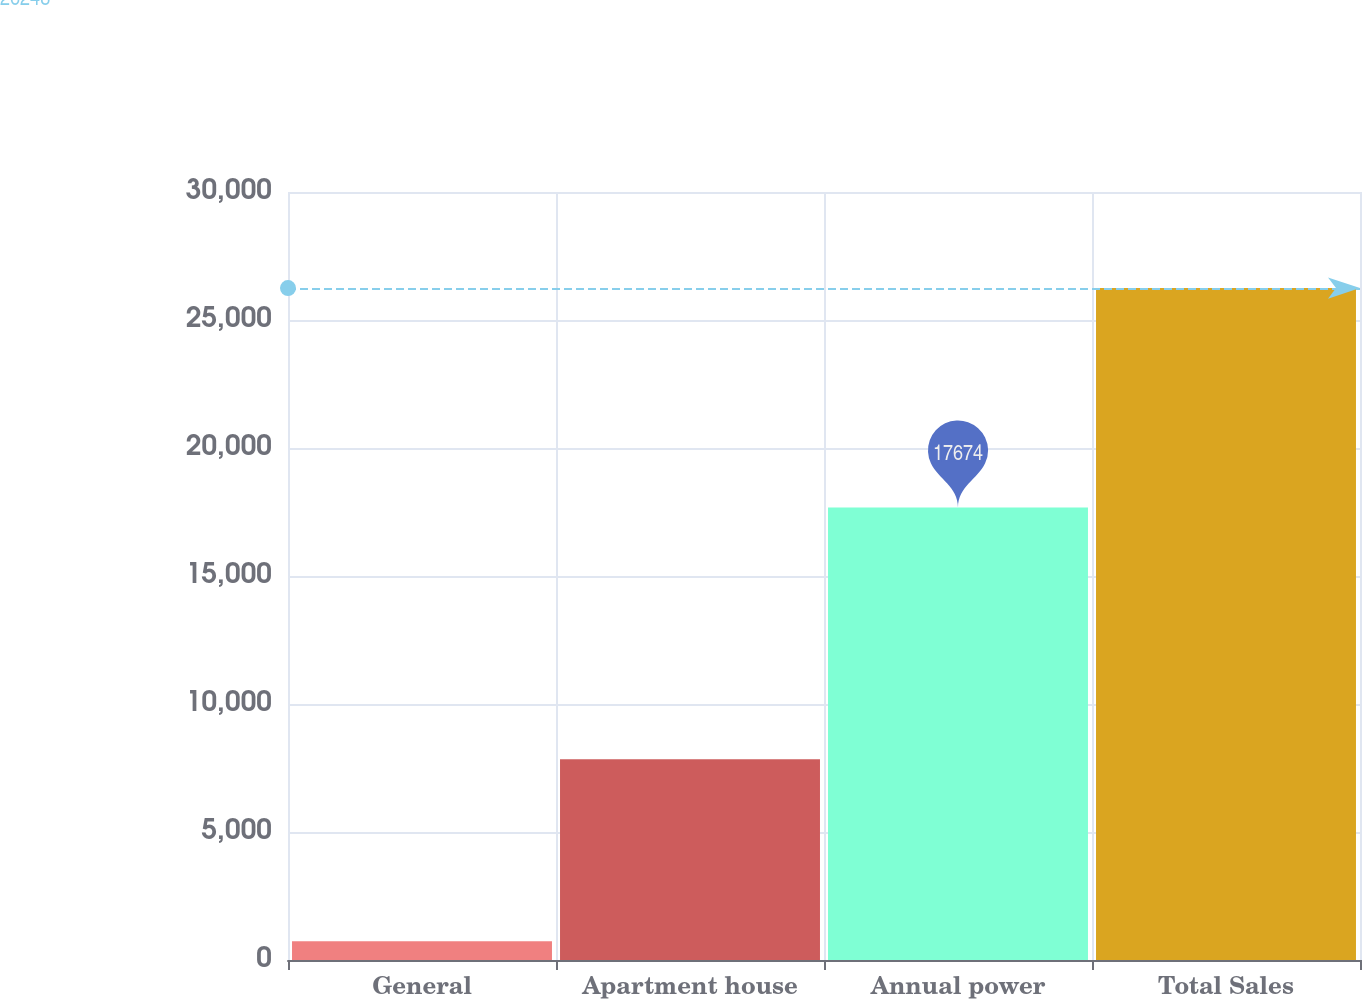<chart> <loc_0><loc_0><loc_500><loc_500><bar_chart><fcel>General<fcel>Apartment house<fcel>Annual power<fcel>Total Sales<nl><fcel>729<fcel>7845<fcel>17674<fcel>26248<nl></chart> 